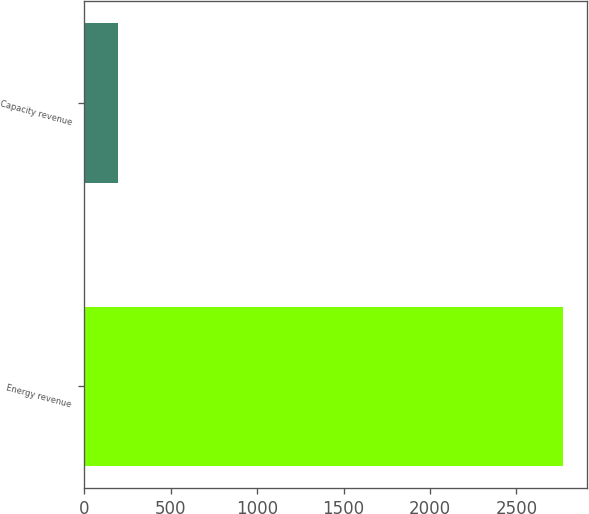Convert chart. <chart><loc_0><loc_0><loc_500><loc_500><bar_chart><fcel>Energy revenue<fcel>Capacity revenue<nl><fcel>2770<fcel>193<nl></chart> 